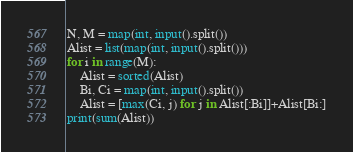<code> <loc_0><loc_0><loc_500><loc_500><_Python_>N, M = map(int, input().split())
Alist = list(map(int, input().split()))
for i in range(M):
    Alist = sorted(Alist)
    Bi, Ci = map(int, input().split())
    Alist = [max(Ci, j) for j in Alist[:Bi]]+Alist[Bi:]
print(sum(Alist))</code> 